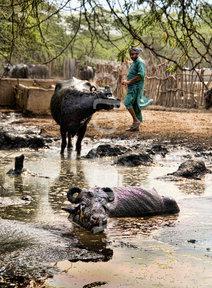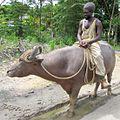The first image is the image on the left, the second image is the image on the right. Examine the images to the left and right. Is the description "Two or more humans are visible." accurate? Answer yes or no. Yes. The first image is the image on the left, the second image is the image on the right. Evaluate the accuracy of this statement regarding the images: "Some animals are laying in mud.". Is it true? Answer yes or no. Yes. 